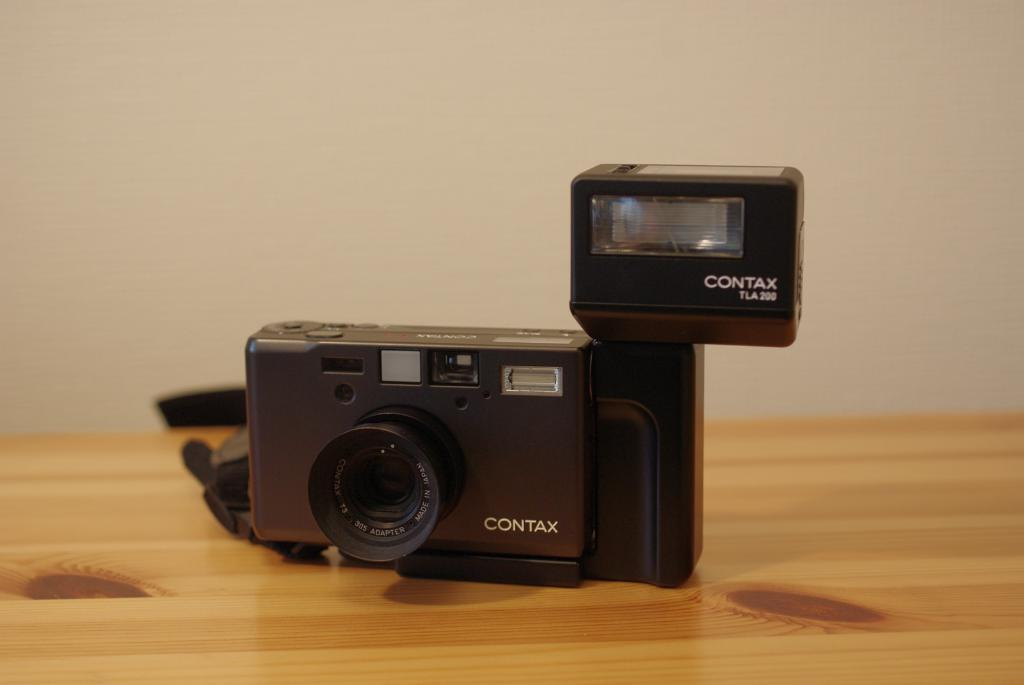Where was the image taken? The image is taken indoors. What can be seen in the background of the image? There is a wall in the background of the image. What is located at the bottom of the image? There is a table at the bottom of the image. What object is on the table in the image? There is a camera on the table in the middle of the image. What type of vase is placed on the table next to the camera in the image? There is no vase present on the table next to the camera in the image. How does the camera say good-bye to the person taking the picture? The camera is an inanimate object and does not have the ability to say good-bye. 